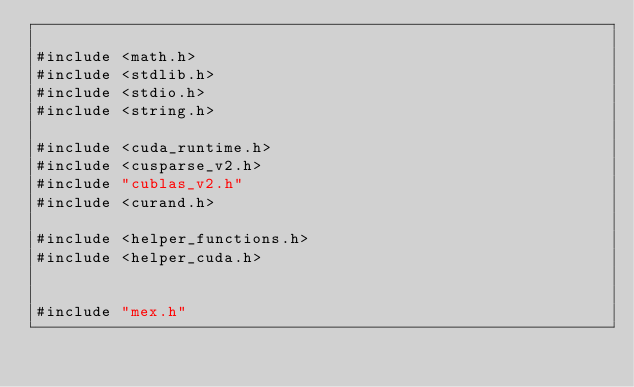Convert code to text. <code><loc_0><loc_0><loc_500><loc_500><_Cuda_>
#include <math.h>
#include <stdlib.h>
#include <stdio.h>
#include <string.h>

#include <cuda_runtime.h>
#include <cusparse_v2.h>
#include "cublas_v2.h"
#include <curand.h>

#include <helper_functions.h>
#include <helper_cuda.h>


#include "mex.h"
</code> 